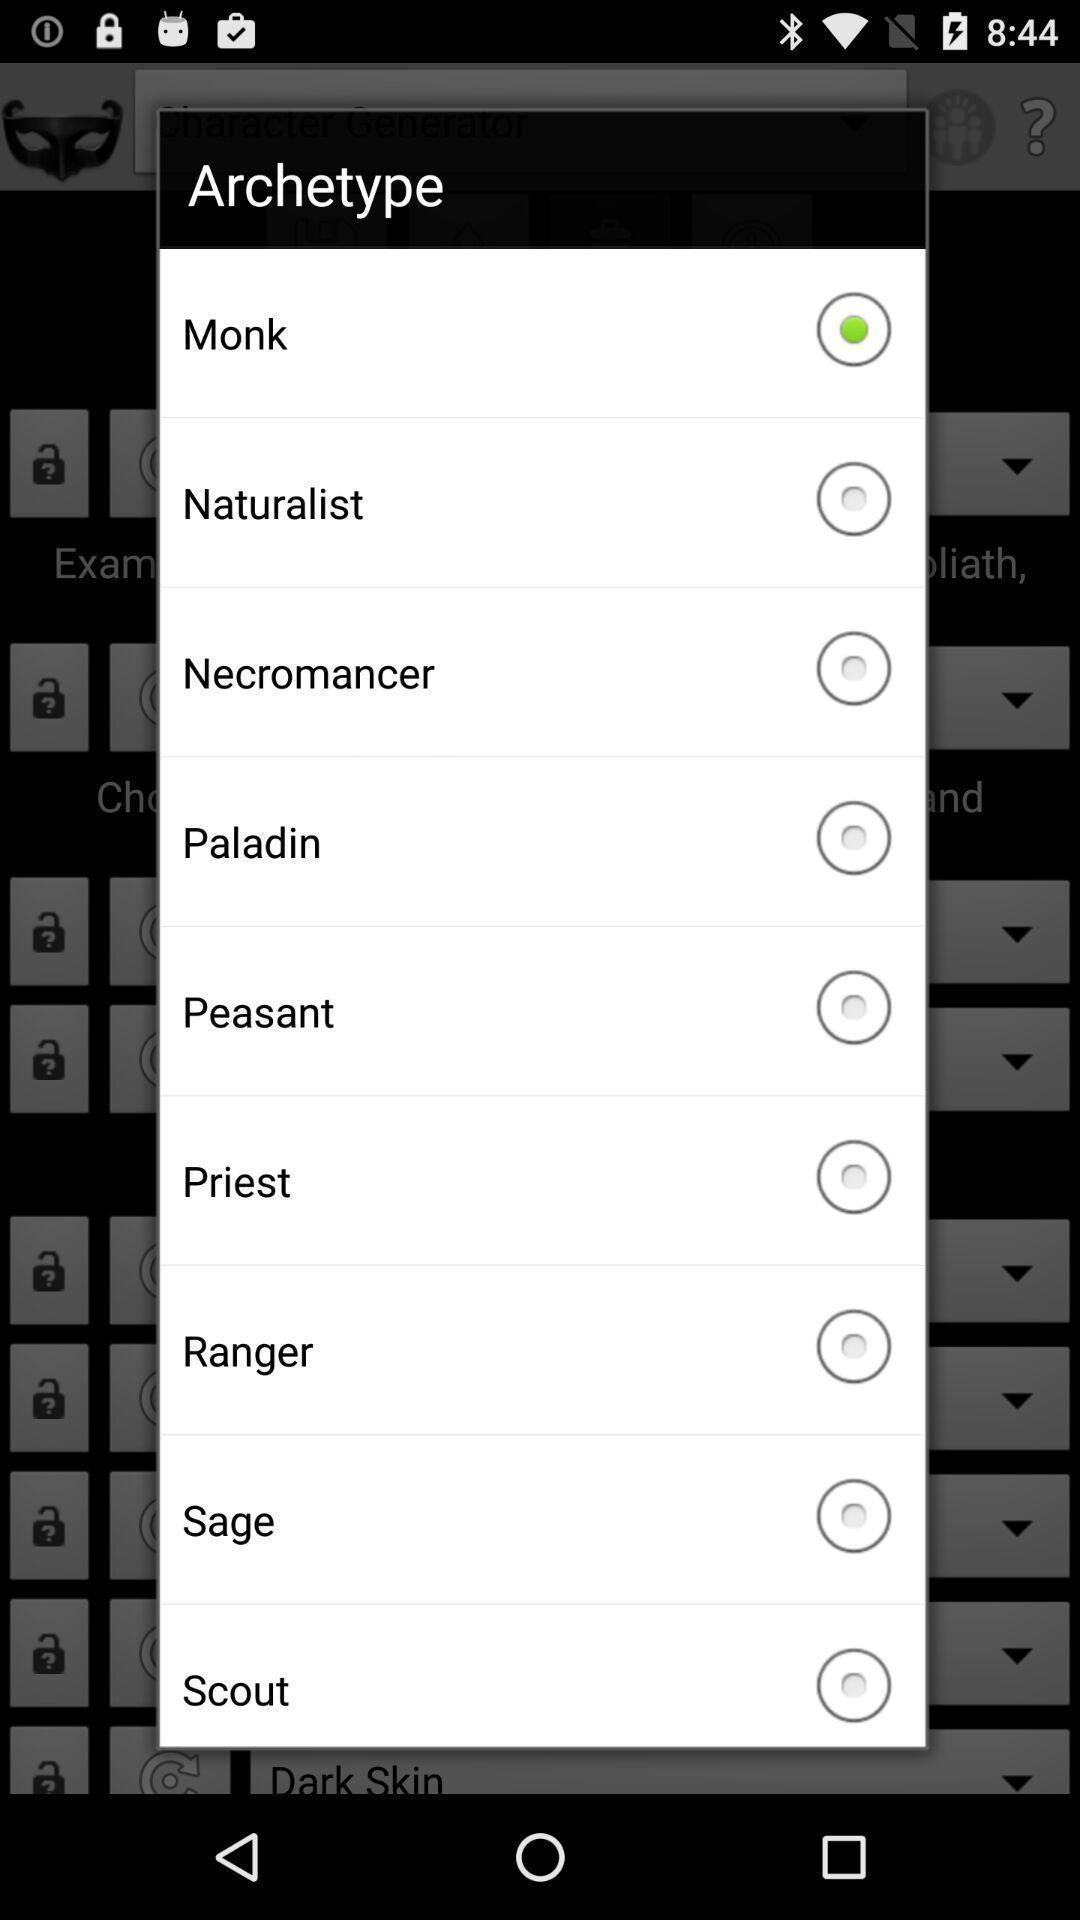Provide a detailed account of this screenshot. Popup of various professions to select in the application. 